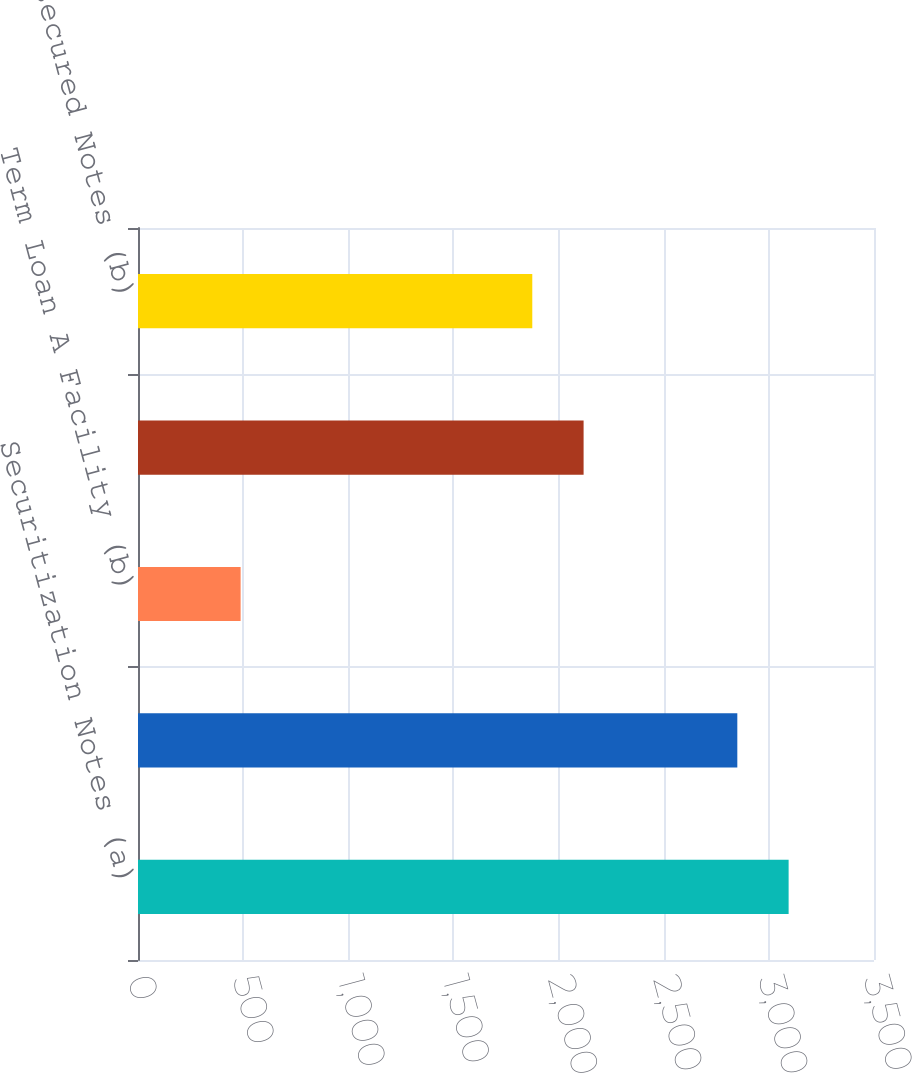Convert chart to OTSL. <chart><loc_0><loc_0><loc_500><loc_500><bar_chart><fcel>Securitization Notes (a)<fcel>Subsidiary Senior Unsecured<fcel>Term Loan A Facility (b)<fcel>Term Loan B Facility (b)<fcel>YUM Senior Unsecured Notes (b)<nl><fcel>3094<fcel>2850<fcel>488<fcel>2119<fcel>1875<nl></chart> 